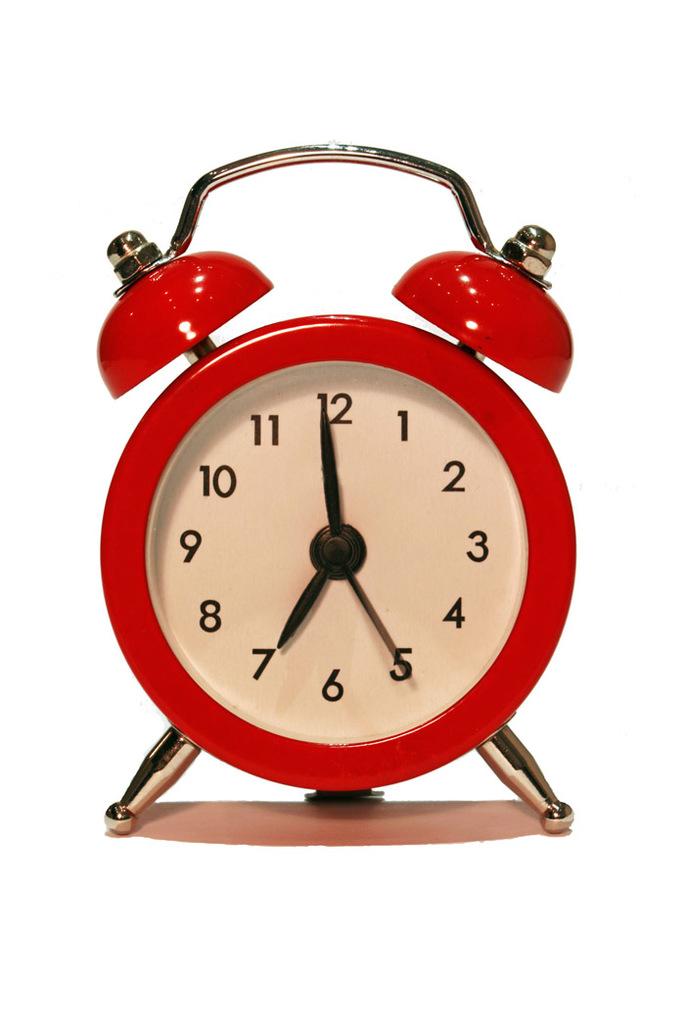What time is it?
Offer a very short reply. 6:59. What number is the second hand on?
Offer a terse response. 5. 